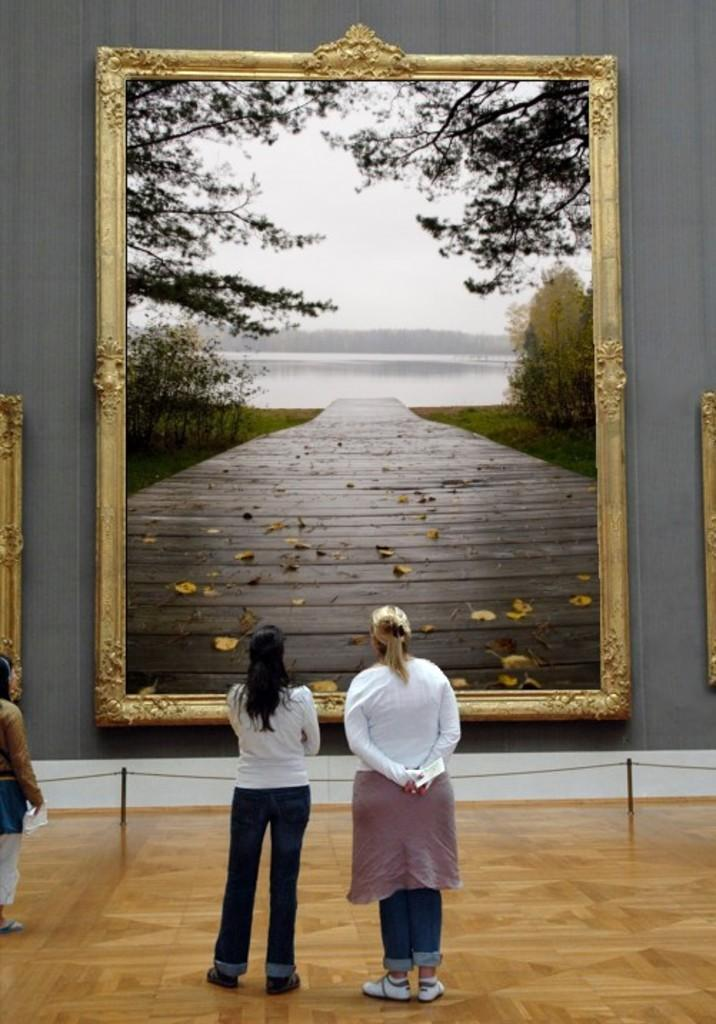What are the people in the image doing? The people in the image are standing on the floor. What can be seen on the wall in the image? There is a large photo frame on a wall in the image. What objects are tied together in the image? There are poles tied with ropes in the image. What type of behavior can be observed in the clocks in the image? There are no clocks present in the image, so it is not possible to observe any behavior. 